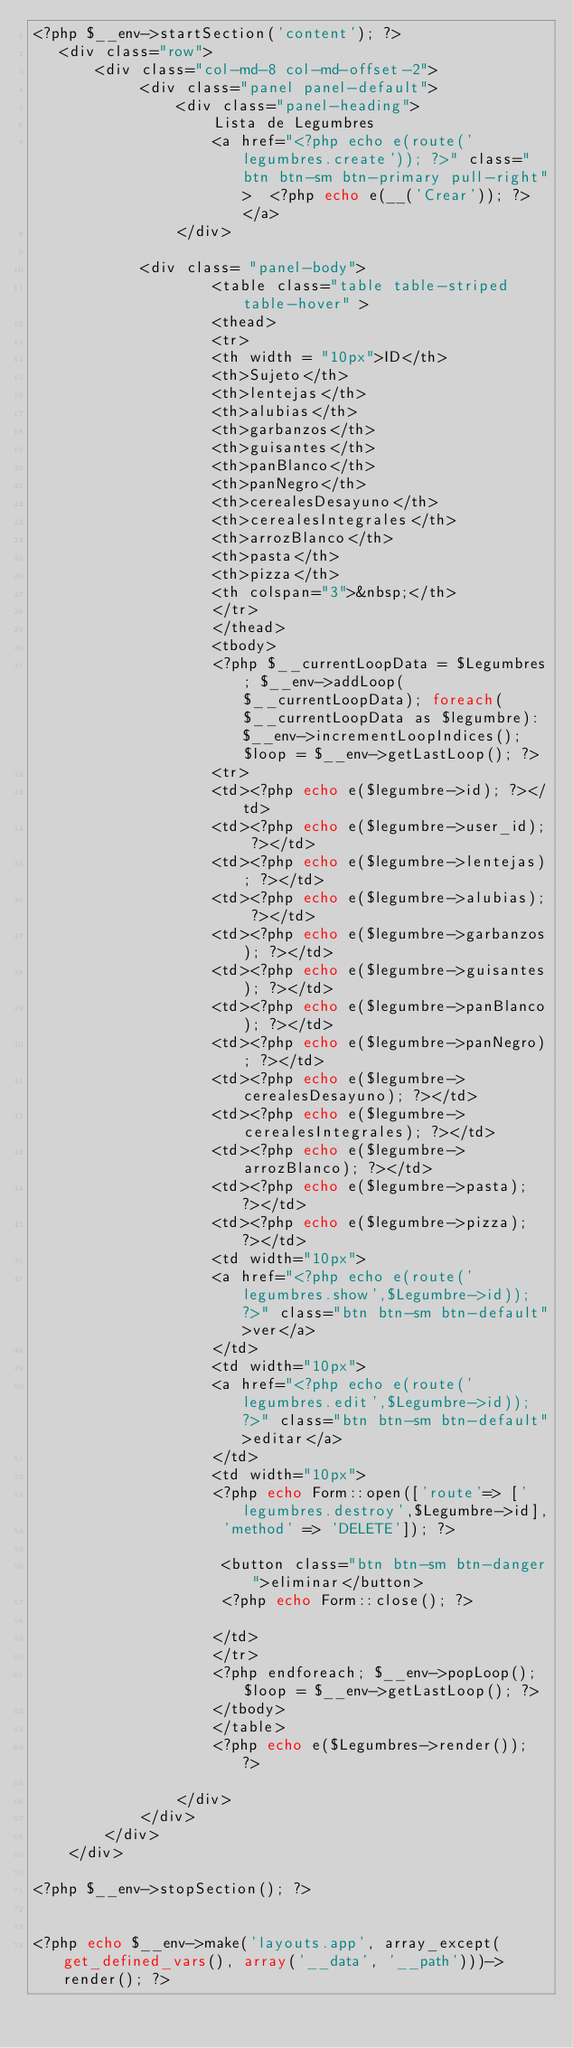Convert code to text. <code><loc_0><loc_0><loc_500><loc_500><_PHP_><?php $__env->startSection('content'); ?>
   <div class="row">
       <div class="col-md-8 col-md-offset-2">
            <div class="panel panel-default">
                <div class="panel-heading">
                    Lista de Legumbres
                    <a href="<?php echo e(route('legumbres.create')); ?>" class="btn btn-sm btn-primary pull-right">  <?php echo e(__('Crear')); ?>  </a>
                </div>
            
            <div class= "panel-body">
                    <table class="table table-striped table-hover" >
                    <thead>
                    <tr>
                    <th width = "10px">ID</th>
                    <th>Sujeto</th>
                    <th>lentejas</th>
                    <th>alubias</th>
                    <th>garbanzos</th>
                    <th>guisantes</th>
                    <th>panBlanco</th>
                    <th>panNegro</th>
                    <th>cerealesDesayuno</th>
                    <th>cerealesIntegrales</th>
                    <th>arrozBlanco</th>
                    <th>pasta</th>
                    <th>pizza</th>
                    <th colspan="3">&nbsp;</th>
                    </tr>
                    </thead>
                    <tbody>
                    <?php $__currentLoopData = $Legumbres; $__env->addLoop($__currentLoopData); foreach($__currentLoopData as $legumbre): $__env->incrementLoopIndices(); $loop = $__env->getLastLoop(); ?>
                    <tr>
                    <td><?php echo e($legumbre->id); ?></td>
                    <td><?php echo e($legumbre->user_id); ?></td>
                    <td><?php echo e($legumbre->lentejas); ?></td>
                    <td><?php echo e($legumbre->alubias); ?></td>
                    <td><?php echo e($legumbre->garbanzos); ?></td>
                    <td><?php echo e($legumbre->guisantes); ?></td>
                    <td><?php echo e($legumbre->panBlanco); ?></td>
                    <td><?php echo e($legumbre->panNegro); ?></td>
                    <td><?php echo e($legumbre->cerealesDesayuno); ?></td>
                    <td><?php echo e($legumbre->cerealesIntegrales); ?></td>
                    <td><?php echo e($legumbre->arrozBlanco); ?></td>
                    <td><?php echo e($legumbre->pasta); ?></td>
                    <td><?php echo e($legumbre->pizza); ?></td>
                    <td width="10px">
                    <a href="<?php echo e(route('legumbres.show',$Legumbre->id)); ?>" class="btn btn-sm btn-default">ver</a>
                    </td>
                    <td width="10px">
                    <a href="<?php echo e(route('legumbres.edit',$Legumbre->id)); ?>" class="btn btn-sm btn-default">editar</a>
                    </td>
                    <td width="10px">
                    <?php echo Form::open(['route'=> ['legumbres.destroy',$Legumbre->id],
                     'method' => 'DELETE']); ?>

                     <button class="btn btn-sm btn-danger">eliminar</button>
                     <?php echo Form::close(); ?>

                    </td>
                    </tr>
                    <?php endforeach; $__env->popLoop(); $loop = $__env->getLastLoop(); ?>
                    </tbody>
                    </table>
                    <?php echo e($Legumbres->render()); ?>

                </div>
            </div>   
        </div>
    </div>
 
<?php $__env->stopSection(); ?>
 

<?php echo $__env->make('layouts.app', array_except(get_defined_vars(), array('__data', '__path')))->render(); ?></code> 